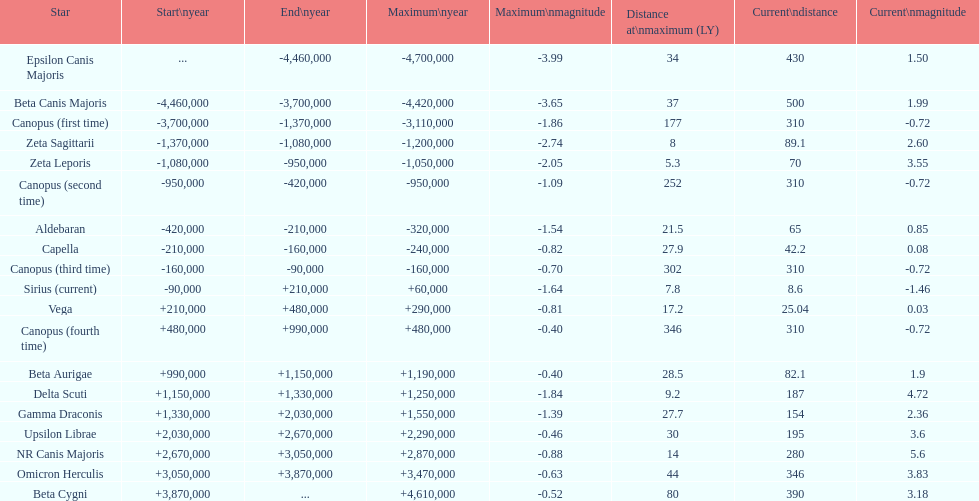Is capella's current magnitude more than vega's current magnitude? Yes. 